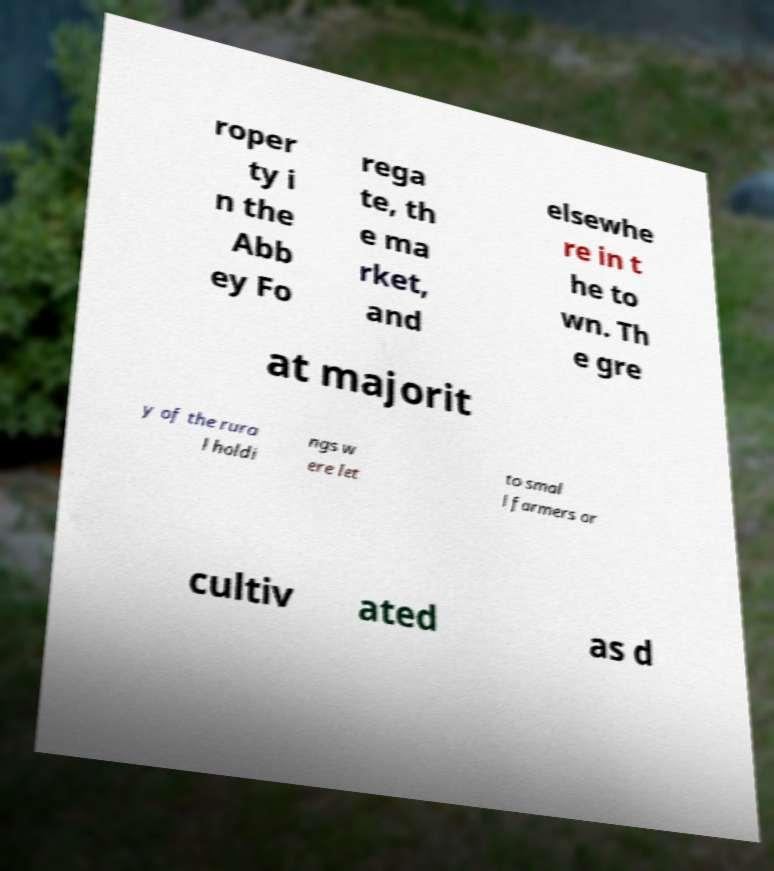Can you read and provide the text displayed in the image?This photo seems to have some interesting text. Can you extract and type it out for me? roper ty i n the Abb ey Fo rega te, th e ma rket, and elsewhe re in t he to wn. Th e gre at majorit y of the rura l holdi ngs w ere let to smal l farmers or cultiv ated as d 